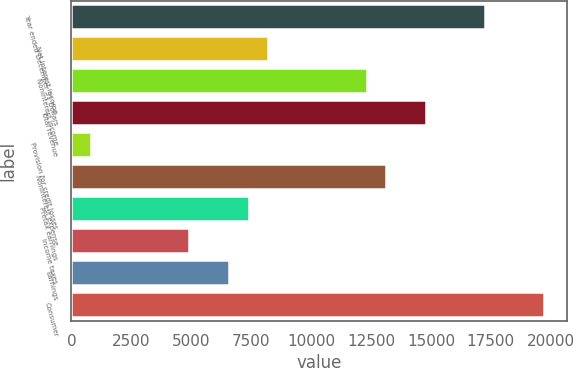Convert chart. <chart><loc_0><loc_0><loc_500><loc_500><bar_chart><fcel>Year ended December 31 Dollars<fcel>Net interest income<fcel>Noninterest income<fcel>Total revenue<fcel>Provision for credit losses<fcel>Noninterest expense<fcel>Pretax earnings<fcel>Income taxes<fcel>Earnings<fcel>Consumer<nl><fcel>17247.1<fcel>8214<fcel>12320<fcel>14783.5<fcel>823.29<fcel>13141.1<fcel>7392.81<fcel>4929.24<fcel>6571.62<fcel>19710.7<nl></chart> 